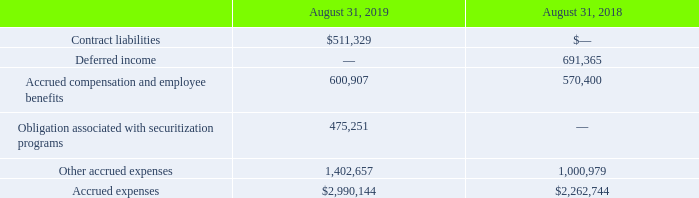7. Accrued Expenses
Accrued expenses consist of the following (in thousands):
What was the contract liabilities in 2019?
Answer scale should be: thousand. $511,329. What was the Accrued compensation and employee benefits in 2018?
Answer scale should be: thousand. 570,400. Which years does the table provide information for on accrued expenses? 2019, 2018. What was the change in Accrued compensation and employee benefits between 2018 and 2019?
Answer scale should be: thousand. 600,907-570,400
Answer: 30507. How many years did accrued expenses exceed $2,000,000 thousand? 2019##2018
Answer: 2. What was the percentage change in accrued expenses between 2018 and 2019?
Answer scale should be: percent. ($2,990,144-$2,262,744)/$2,262,744
Answer: 32.15. 